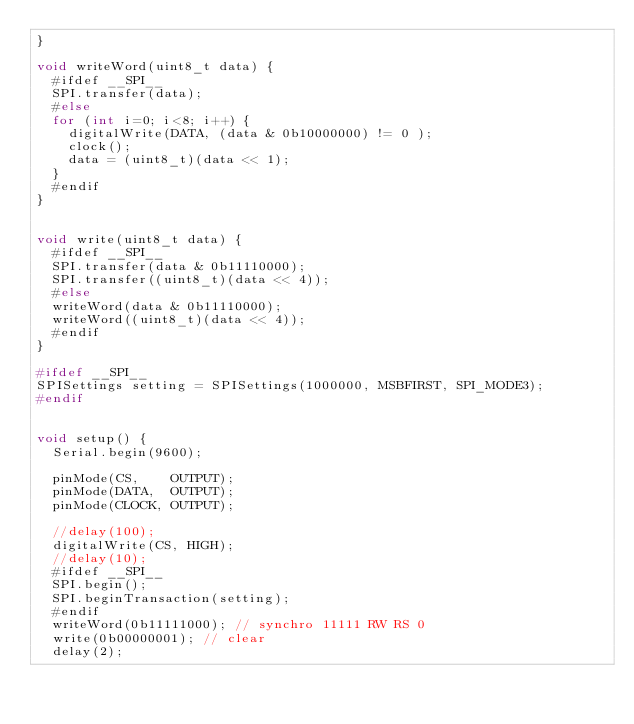<code> <loc_0><loc_0><loc_500><loc_500><_C++_>}

void writeWord(uint8_t data) {
  #ifdef __SPI__
  SPI.transfer(data);
  #else
  for (int i=0; i<8; i++) {
    digitalWrite(DATA, (data & 0b10000000) != 0 );
    clock();
    data = (uint8_t)(data << 1);
  }
  #endif
}


void write(uint8_t data) {
  #ifdef __SPI__
  SPI.transfer(data & 0b11110000);
  SPI.transfer((uint8_t)(data << 4));
  #else
  writeWord(data & 0b11110000);
  writeWord((uint8_t)(data << 4));
  #endif
}

#ifdef __SPI__
SPISettings setting = SPISettings(1000000, MSBFIRST, SPI_MODE3);
#endif


void setup() {
  Serial.begin(9600);

  pinMode(CS,    OUTPUT);
  pinMode(DATA,  OUTPUT);
  pinMode(CLOCK, OUTPUT);

  //delay(100);
  digitalWrite(CS, HIGH);
  //delay(10);
  #ifdef __SPI__
  SPI.begin();
  SPI.beginTransaction(setting);
  #endif
  writeWord(0b11111000); // synchro 11111 RW RS 0
  write(0b00000001); // clear
  delay(2);</code> 